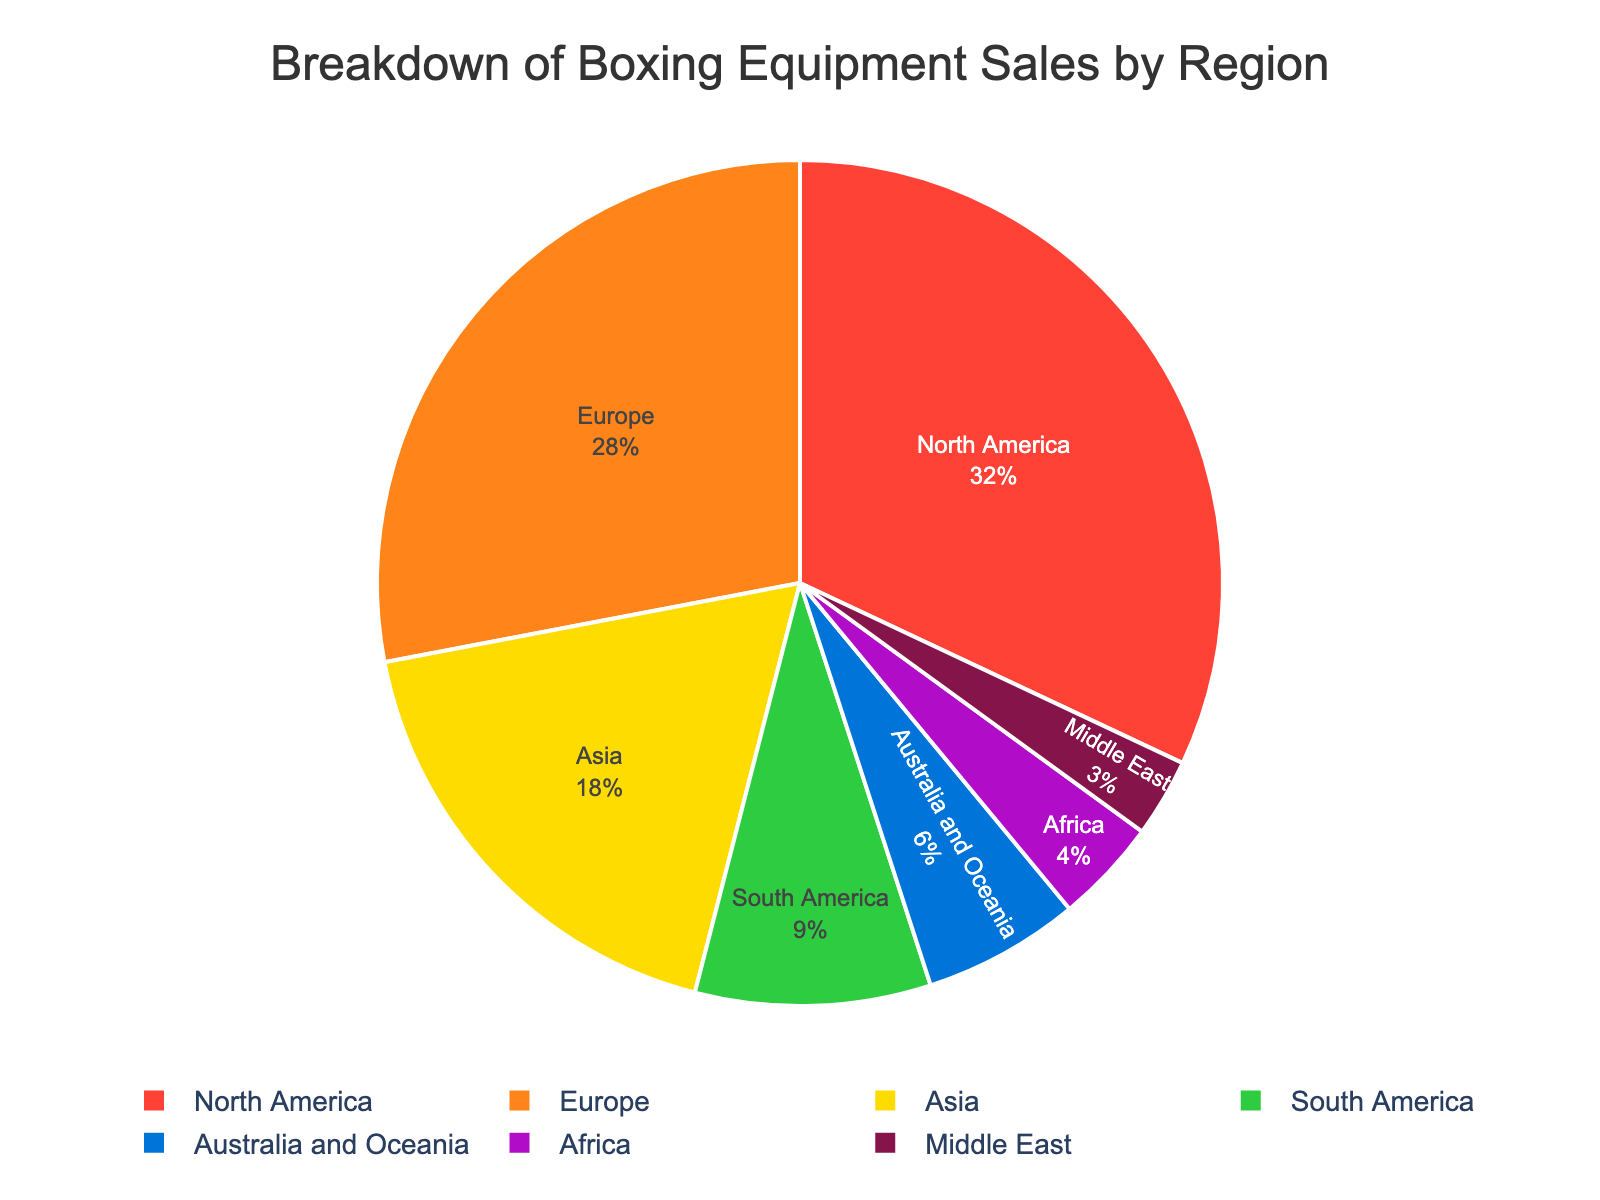Which region has the highest percentage of sales? The segment with the highest percentage visually occupies the largest portion of the pie chart. In this chart, North America has the largest portion.
Answer: North America Which two regions together cover more than half of the sales? To determine which two regions cover more than half of the sales, you need to find regions whose combined percentage exceeds 50%. North America (32%) and Europe (28%) together sum to 60%, which is more than half.
Answer: North America and Europe What is the difference in sales percentage between North America and Europe? To find the difference, subtract the percentage of sales in Europe from the percentage in North America. 32% (North America) - 28% (Europe) = 4%.
Answer: 4% Which region has the smallest share in the market? The segment that is the smallest visually indicates the region with the smallest percentage. In this case, it is the Middle East with a 3% share.
Answer: Middle East How do the sales in Asia compare to those in South America? To compare the sales, you look at the percentages for Asia (18%) and South America (9%). Asia has twice the market share of South America.
Answer: Asia has twice the sales percentage as South America What is the combined sales percentage of Africa and the Middle East? Sum the sales percentages for Africa and the Middle East: 4% (Africa) + 3% (Middle East) = 7%.
Answer: 7% By how much does Australia's sales percentage exceed that of Africa's? Subtract the percentage of sales in Africa from the percentage in Australia and Oceania. 6% (Australia and Oceania) - 4% (Africa) = 2%.
Answer: 2% Which region, apart from North America and Europe, contributes the most to the sales? Excluding North America (32%) and Europe (28%), the next largest segment visually on the chart is Asia with 18%.
Answer: Asia What's the average percentage of sales among South America, Australia and Oceania, and Africa? Sum the percentages of these three regions and then divide by the number of regions: (9% + 6% + 4%) / 3 = 19% / 3 ≈ 6.33%.
Answer: 6.33% Is the market share in Australia smaller or larger than in Africa and the Middle East combined? Combine the percentages of Africa and the Middle East: 4% (Africa) + 3% (Middle East) = 7%. Australia's share is 6%, which is smaller.
Answer: Smaller 